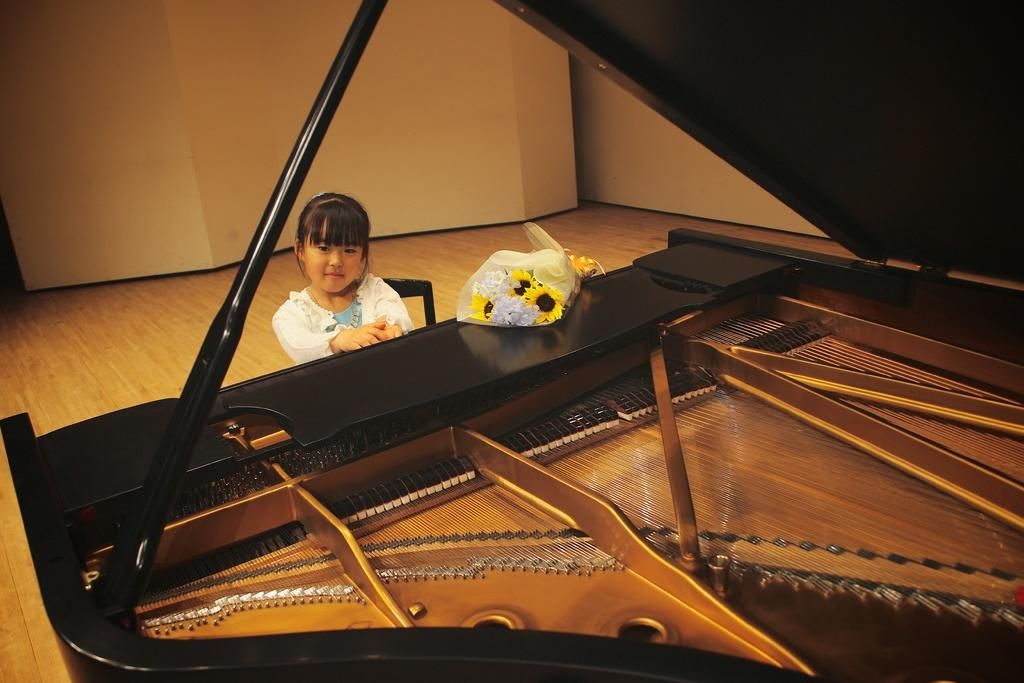What is the main subject of the image? There is a child in the image. What is the child doing in the image? The child is sitting in front of a piano. What other objects can be seen in the image? There is a bouquet in the image. What is visible in the background of the image? There is a wall in the background of the image. What type of whip is the child using to paint the wall in the image? There is no whip or painting activity present in the image. How many kisses can be seen on the child's face in the image? There are no kisses visible on the child's face in the image. 